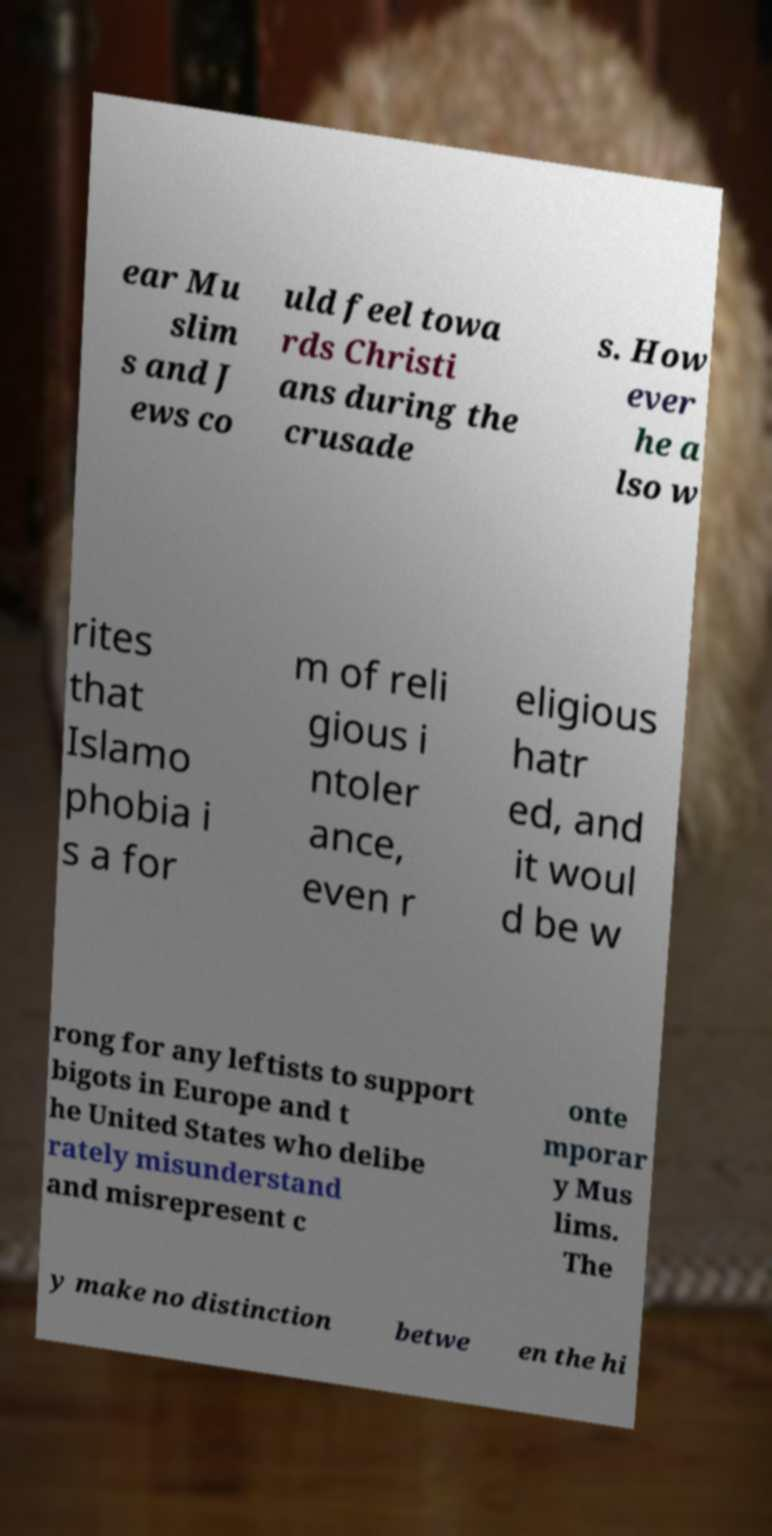Please read and relay the text visible in this image. What does it say? ear Mu slim s and J ews co uld feel towa rds Christi ans during the crusade s. How ever he a lso w rites that Islamo phobia i s a for m of reli gious i ntoler ance, even r eligious hatr ed, and it woul d be w rong for any leftists to support bigots in Europe and t he United States who delibe rately misunderstand and misrepresent c onte mporar y Mus lims. The y make no distinction betwe en the hi 